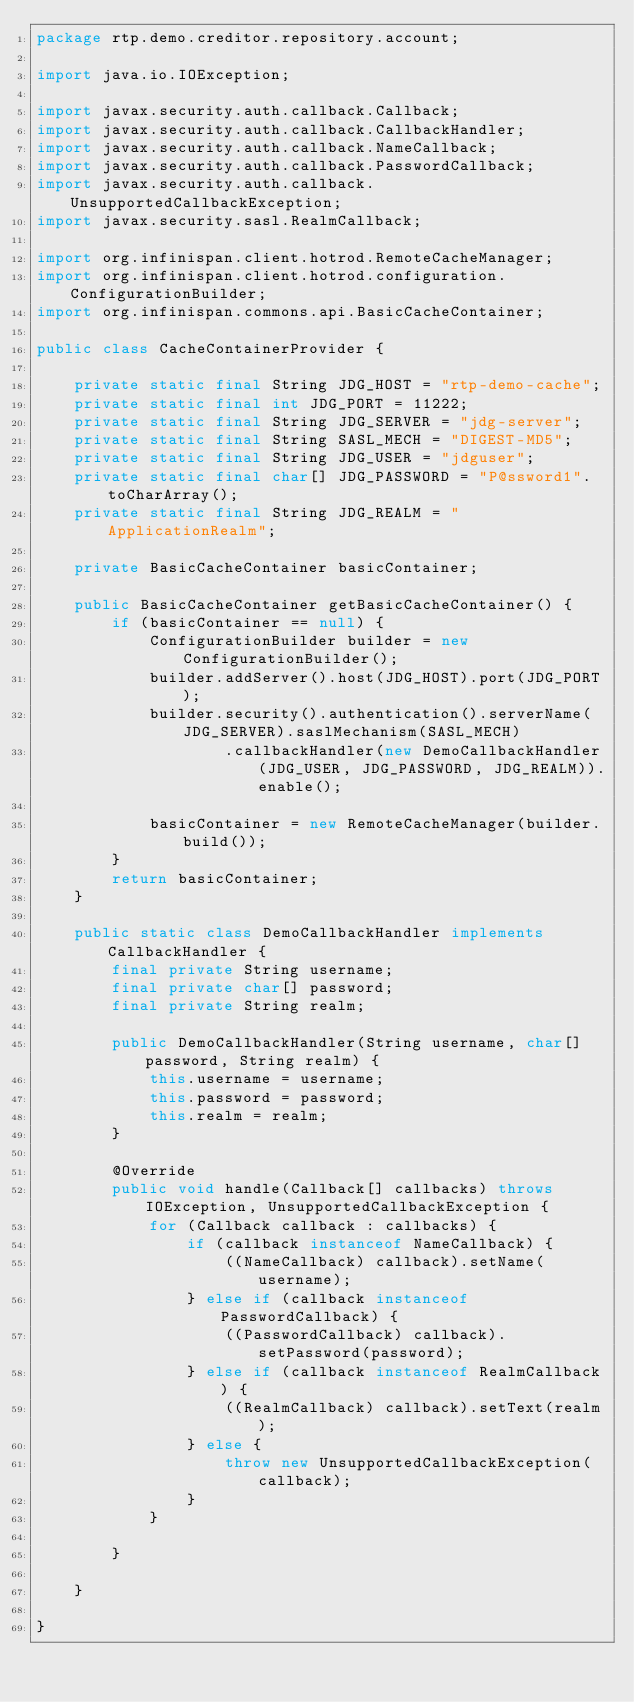<code> <loc_0><loc_0><loc_500><loc_500><_Java_>package rtp.demo.creditor.repository.account;

import java.io.IOException;

import javax.security.auth.callback.Callback;
import javax.security.auth.callback.CallbackHandler;
import javax.security.auth.callback.NameCallback;
import javax.security.auth.callback.PasswordCallback;
import javax.security.auth.callback.UnsupportedCallbackException;
import javax.security.sasl.RealmCallback;

import org.infinispan.client.hotrod.RemoteCacheManager;
import org.infinispan.client.hotrod.configuration.ConfigurationBuilder;
import org.infinispan.commons.api.BasicCacheContainer;

public class CacheContainerProvider {

	private static final String JDG_HOST = "rtp-demo-cache";
	private static final int JDG_PORT = 11222;
	private static final String JDG_SERVER = "jdg-server";
	private static final String SASL_MECH = "DIGEST-MD5";
	private static final String JDG_USER = "jdguser";
	private static final char[] JDG_PASSWORD = "P@ssword1".toCharArray();
	private static final String JDG_REALM = "ApplicationRealm";

	private BasicCacheContainer basicContainer;

	public BasicCacheContainer getBasicCacheContainer() {
		if (basicContainer == null) {
			ConfigurationBuilder builder = new ConfigurationBuilder();
			builder.addServer().host(JDG_HOST).port(JDG_PORT);
			builder.security().authentication().serverName(JDG_SERVER).saslMechanism(SASL_MECH)
					.callbackHandler(new DemoCallbackHandler(JDG_USER, JDG_PASSWORD, JDG_REALM)).enable();

			basicContainer = new RemoteCacheManager(builder.build());
		}
		return basicContainer;
	}

	public static class DemoCallbackHandler implements CallbackHandler {
		final private String username;
		final private char[] password;
		final private String realm;

		public DemoCallbackHandler(String username, char[] password, String realm) {
			this.username = username;
			this.password = password;
			this.realm = realm;
		}

		@Override
		public void handle(Callback[] callbacks) throws IOException, UnsupportedCallbackException {
			for (Callback callback : callbacks) {
				if (callback instanceof NameCallback) {
					((NameCallback) callback).setName(username);
				} else if (callback instanceof PasswordCallback) {
					((PasswordCallback) callback).setPassword(password);
				} else if (callback instanceof RealmCallback) {
					((RealmCallback) callback).setText(realm);
				} else {
					throw new UnsupportedCallbackException(callback);
				}
			}

		}

	}

}</code> 